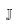<formula> <loc_0><loc_0><loc_500><loc_500>\mathbb { J }</formula> 